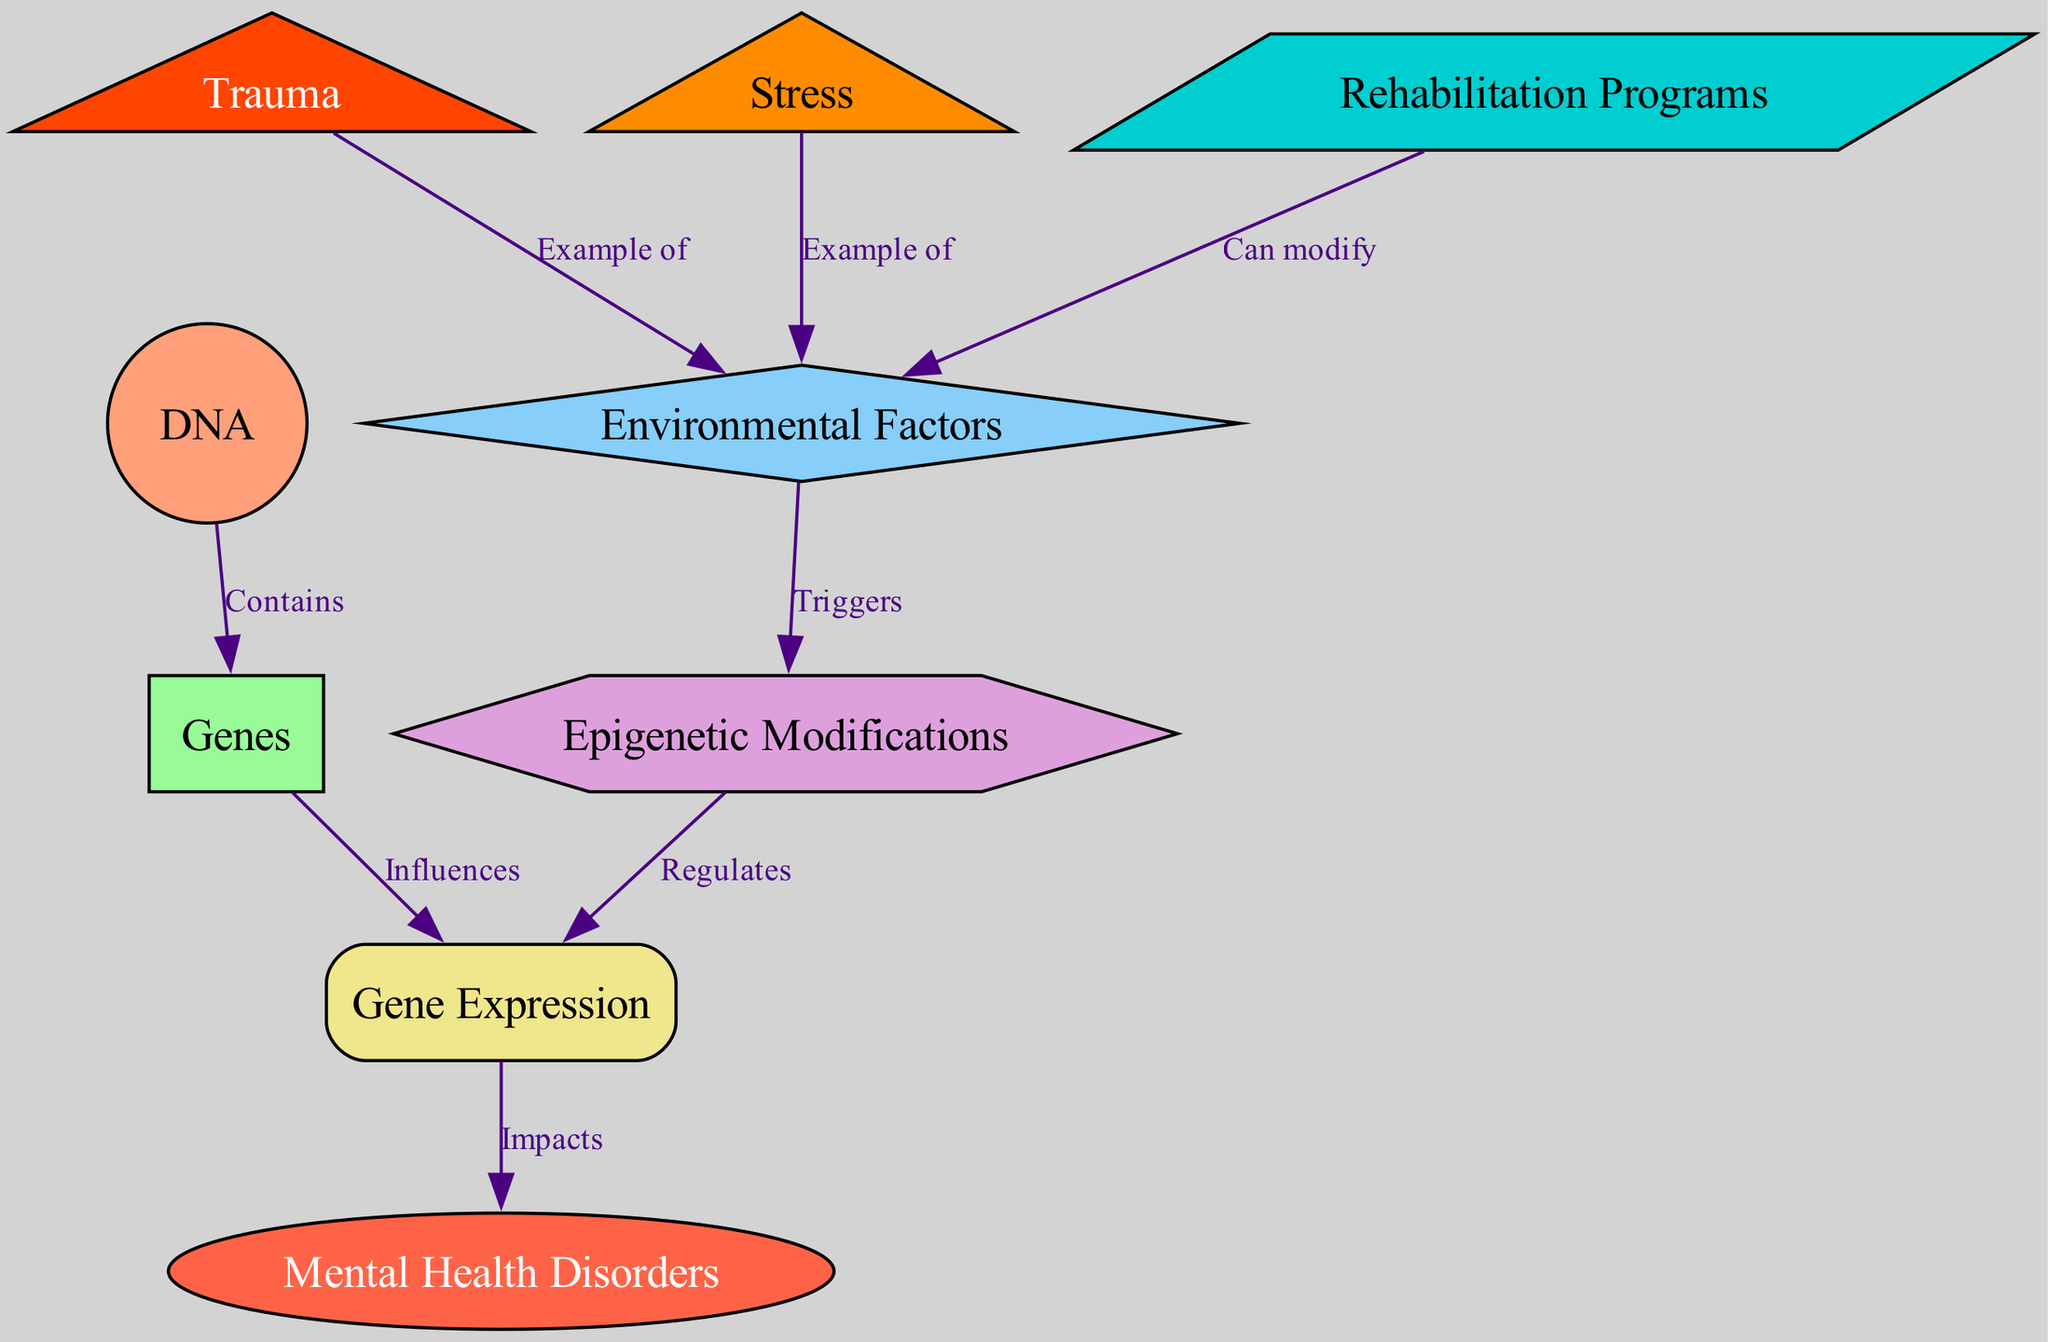What are the two examples of environmental factors in the diagram? The diagram lists "Trauma" and "Stress" as examples of environmental factors, shown by their connections to the node "Environmental Factors".
Answer: Trauma, Stress How many nodes are present in the diagram? The diagram contains a total of 9 nodes representing various components of the genetic and environmental factors influencing mental health disorders.
Answer: 9 What type of modification does the node "Epigenetic Modifications" represent? The node "Epigenetic Modifications" is represented as a hexagon, indicating its specific nature in the context of the diagram.
Answer: Hexagon Which node influences gene expression according to the diagram? The diagram shows that the node "Genes" influences the node "Gene Expression" through a directed edge connecting them.
Answer: Genes What impact do environmental factors have on epigenetic modifications? The diagram indicates that environmental factors "Trigger" epigenetic modifications, establishing a direct relationship between these two nodes.
Answer: Triggers How do rehabilitation programs relate to environmental factors? The diagram illustrates that "Rehabilitation Programs" can modify environmental factors, indicating their role in influencing mental health through intervention.
Answer: Can modify What is the final impact of gene expression as shown in the diagram? The final impact of gene expression is shown to be on "Mental Health Disorders," indicating a direct pathway from genetic expression to disorders.
Answer: Impacts What connects DNA to the genes represented in the diagram? The connection between DNA and Genes is specified by the relationship labeled "Contains", indicating that genes are part of the DNA structure.
Answer: Contains Which environmental factor is specifically linked to trauma in the diagram? The diagram specifically shows "Trauma" as an example of an environmental factor that can affect mental health disorders, demonstrating its detrimental role.
Answer: Example of 